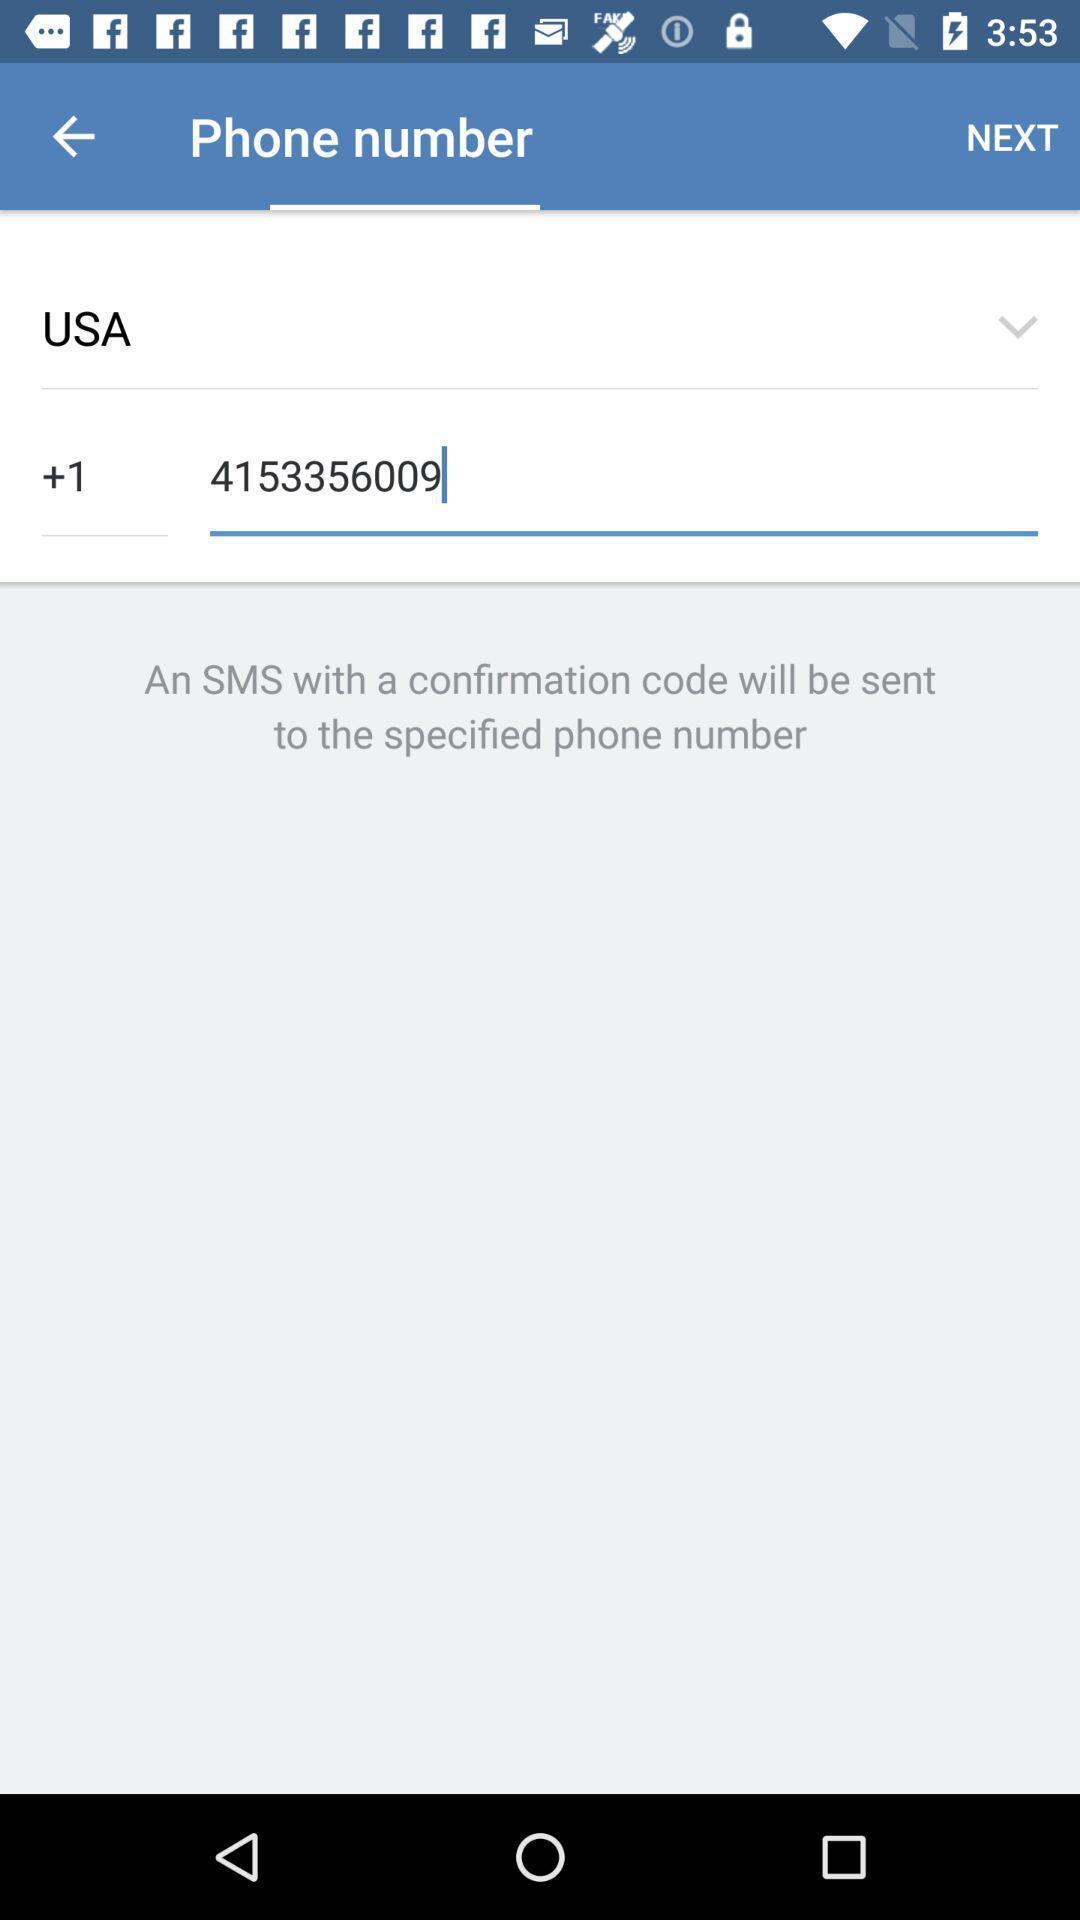Give me a summary of this screen capture. Verification page to confirm number. 